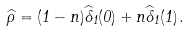Convert formula to latex. <formula><loc_0><loc_0><loc_500><loc_500>\widehat { \rho } = ( 1 - n ) \widehat { \Lambda } _ { 1 } ( 0 ) + n \widehat { \Lambda } _ { 1 } ( 1 ) \, .</formula> 